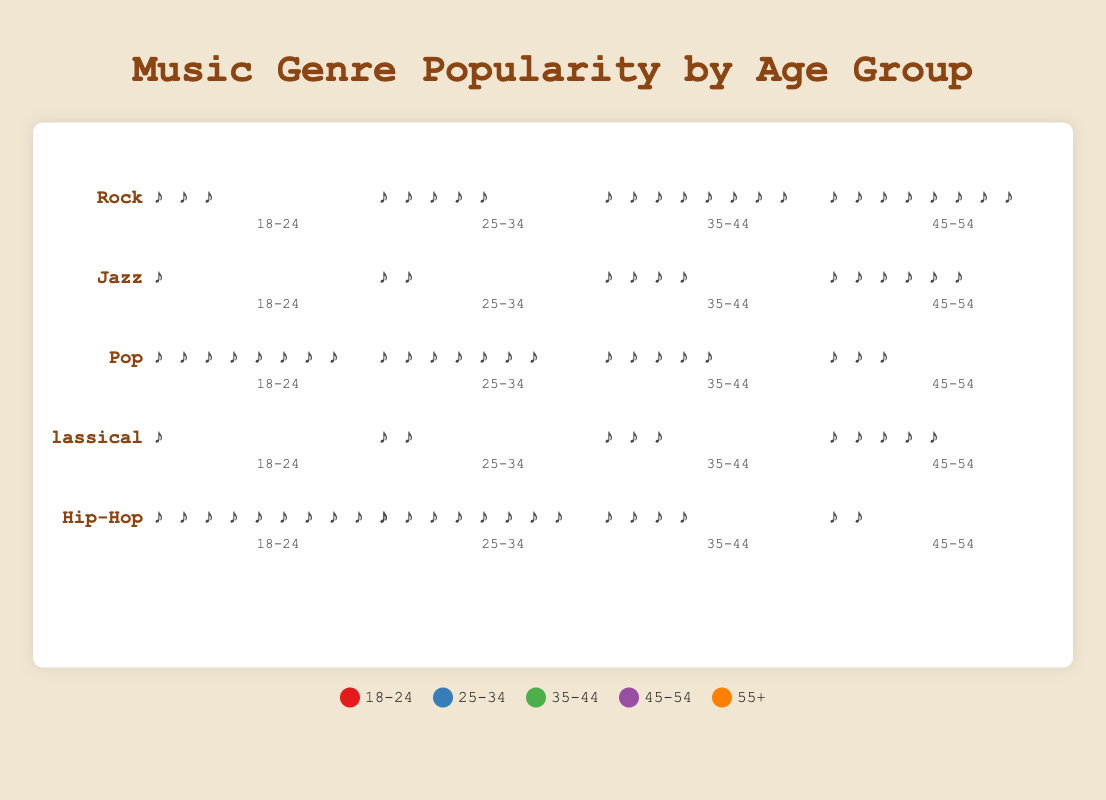What is the most popular music genre among the 18-24 age group? In the "18-24" age group column, find the genre with the highest number of icons/symbols. "Hip-Hop" has 10 symbols, the highest among all genres.
Answer: Hip-Hop Which age group has the least interest in Jazz music? In the Jazz row, look for the age group with the fewest number of symbols. The "18-24" age group has 1 symbol, the lowest.
Answer: 18-24 Compare the popularity of Rock and Classical music among the 45-54 age group. Which one is more popular? Check the number of symbols for Rock and Classical in the "45-54" age group. Rock has 10 symbols, and Classical has 5 symbols. Rock is more popular.
Answer: Rock What is the total number of people in the 35-44 age group listening to either Jazz or Pop? Sum the symbols for Jazz and Pop in the "35-44" age group. Jazz has 4, and Pop has 5. The total is 4 + 5 = 9.
Answer: 9 Which genre has an almost even distribution across all age groups? Look for the genre with similar counts of symbols across all age groups. Classical and Jazz show similar counts across the age groups, but Classical is more even (1, 2, 3, 5, 8).
Answer: Classical What is the difference between the number of people in the 55+ age group listening to Hip-Hop and the number listening to Rock? Find the number of symbols for Hip-Hop and Rock in the "55+" age group. Hip-Hop has 1 symbol, and Rock has 7. The difference is 7 - 1 = 6.
Answer: 6 Which age group shows the highest interest in any genre? Check the maximum number of symbols in each age group across all genres. The "18-24" age group for Hip-Hop has the highest total of 10 symbols.
Answer: 18-24 in Hip-Hop What is the sum of people in the 25-34 age group listening to all genres? Sum the symbols in the "25-34" age group across all genres (Rock: 5, Jazz: 2, Pop: 7, Classical: 2, Hip-Hop: 8). The total is 5 + 2 + 7 + 2 + 8 = 24.
Answer: 24 How does the popularity of Pop compare between the 25-34 and 55+ age groups? Compare the number of symbols for Pop in the "25-34" and "55+" age groups. "25-34" has 7 symbols, and "55+" has 2 symbols. Pop is more popular in the 25-34 age group.
Answer: 25-34 Which genre sees the most growth in popularity from the 18-24 to the 45-54 age group? For each genre, subtract the number of symbols in the "18-24" age group from the "45-54" age group. Classical increases from 1 to 5, showing the most growth (4 symbols).
Answer: Classical 